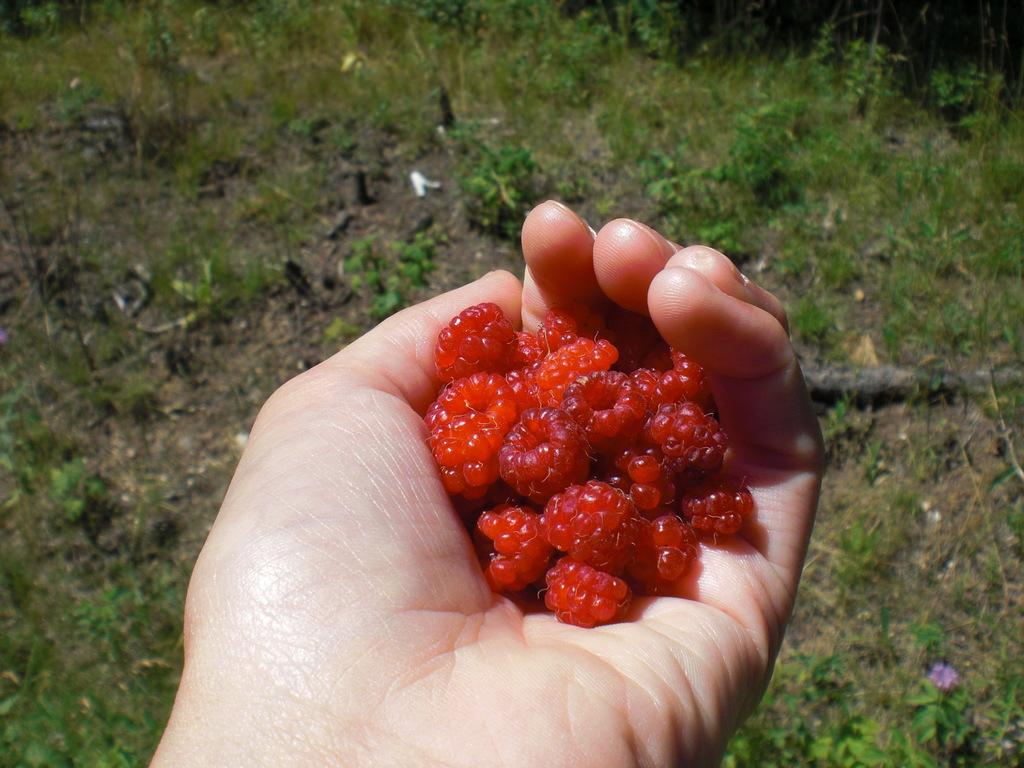What is the person holding in the image? The person is holding red color fruits with a hand. What can be seen in the background of the image? There are plants and grass on the ground in the background of the image. How does the person exchange the fruits with the plants in the image? There is no exchange of fruits with the plants in the image; the person is simply holding the fruits. 